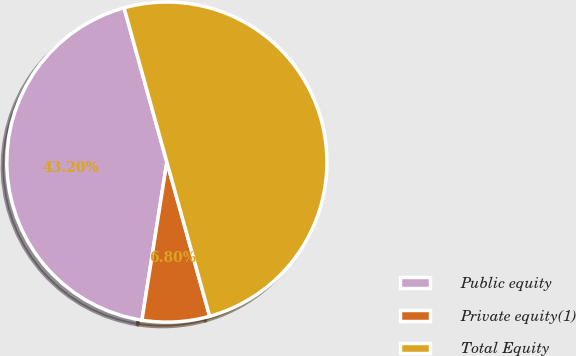Convert chart. <chart><loc_0><loc_0><loc_500><loc_500><pie_chart><fcel>Public equity<fcel>Private equity(1)<fcel>Total Equity<nl><fcel>43.2%<fcel>6.8%<fcel>50.0%<nl></chart> 